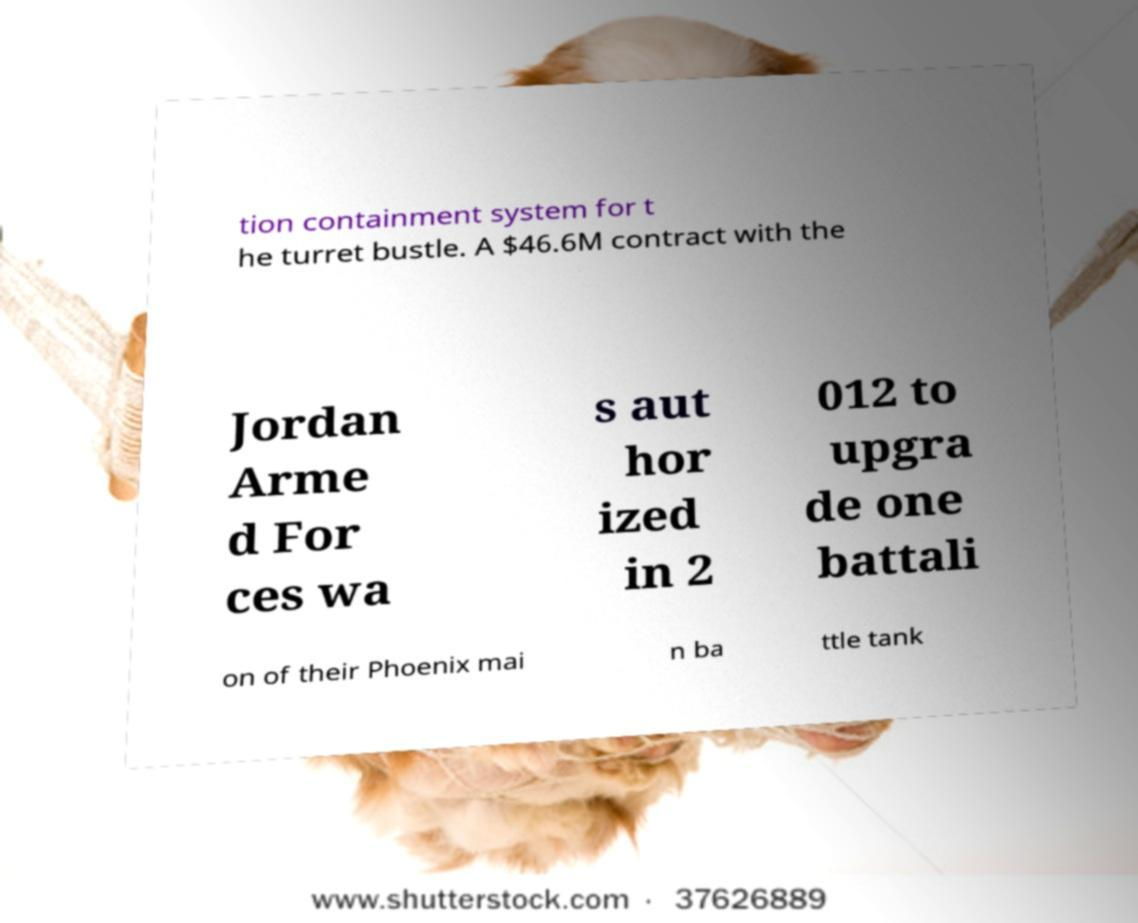Could you extract and type out the text from this image? tion containment system for t he turret bustle. A $46.6M contract with the Jordan Arme d For ces wa s aut hor ized in 2 012 to upgra de one battali on of their Phoenix mai n ba ttle tank 